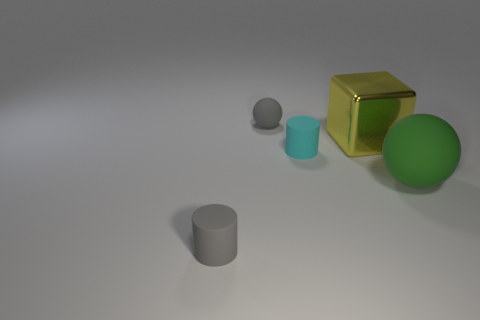There is a sphere that is the same size as the yellow metallic thing; what material is it?
Ensure brevity in your answer.  Rubber. There is a metallic thing behind the object that is right of the big yellow block; are there any tiny gray objects that are in front of it?
Ensure brevity in your answer.  Yes. Is there any other thing that is the same shape as the large metal thing?
Offer a very short reply. No. Is the color of the thing behind the yellow metallic cube the same as the small cylinder in front of the cyan matte cylinder?
Offer a terse response. Yes. Are any large purple matte objects visible?
Keep it short and to the point. No. There is a cylinder that is the same color as the small rubber ball; what material is it?
Your answer should be compact. Rubber. What is the size of the green rubber sphere that is in front of the matte cylinder behind the tiny cylinder that is on the left side of the small rubber sphere?
Offer a very short reply. Large. Do the green matte thing and the small gray rubber object that is behind the large rubber sphere have the same shape?
Provide a short and direct response. Yes. Are there any matte objects of the same color as the small rubber ball?
Offer a very short reply. Yes. What number of balls are big yellow metallic objects or large objects?
Give a very brief answer. 1. 